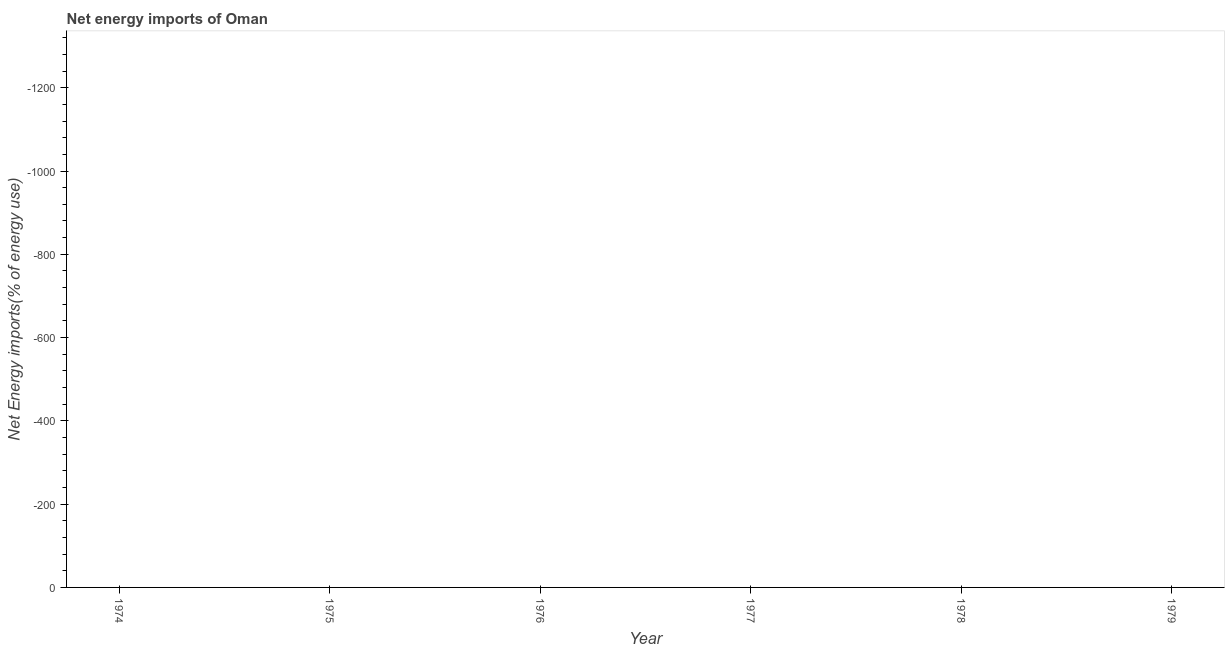Across all years, what is the minimum energy imports?
Your answer should be very brief. 0. What is the average energy imports per year?
Keep it short and to the point. 0. In how many years, is the energy imports greater than -1320 %?
Your response must be concise. 0. Are the values on the major ticks of Y-axis written in scientific E-notation?
Offer a terse response. No. Does the graph contain any zero values?
Offer a terse response. Yes. What is the title of the graph?
Offer a terse response. Net energy imports of Oman. What is the label or title of the Y-axis?
Your response must be concise. Net Energy imports(% of energy use). What is the Net Energy imports(% of energy use) of 1974?
Provide a succinct answer. 0. What is the Net Energy imports(% of energy use) in 1978?
Your answer should be very brief. 0. 